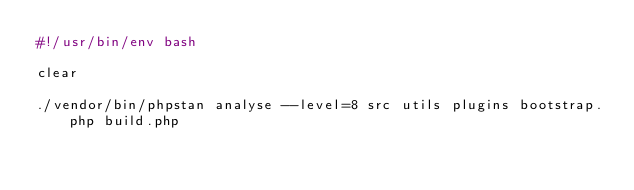<code> <loc_0><loc_0><loc_500><loc_500><_Bash_>#!/usr/bin/env bash

clear

./vendor/bin/phpstan analyse --level=8 src utils plugins bootstrap.php build.php

</code> 